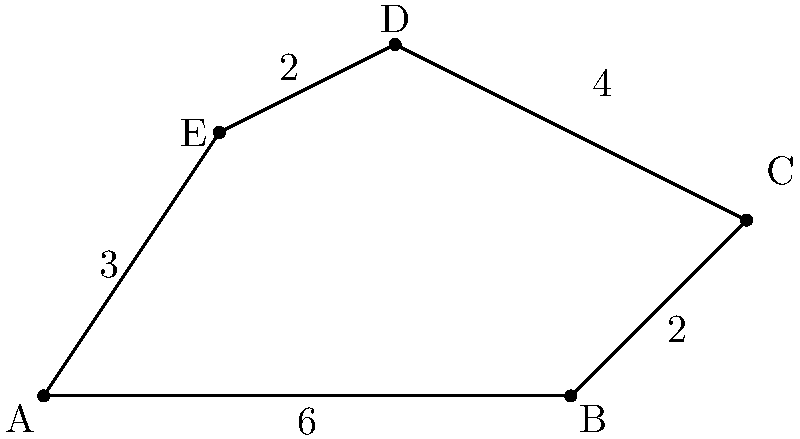In the context of poststructuralist analysis, consider the irregular pentagon ABCDE as a representation of the complex network of meanings in a text. If each unit of area corresponds to a layer of interpretation, calculate the total area of this textual landscape. Assume that the coordinates of the vertices are A(0,0), B(6,0), C(8,2), D(4,4), and E(2,3). To find the area of this irregular pentagon, we can use the shoelace formula (also known as the surveyor's formula). This method is particularly apt for our poststructuralist approach, as it weaves together different points to create a cohesive whole, much like how Derrida's theory of deconstruction reveals the interplay of meanings within a text.

Step 1: Apply the shoelace formula.
Area = $\frac{1}{2}|(x_1y_2 + x_2y_3 + x_3y_4 + x_4y_5 + x_5y_1) - (y_1x_2 + y_2x_3 + y_3x_4 + y_4x_5 + y_5x_1)|$

Step 2: Substitute the coordinates.
Area = $\frac{1}{2}|[(0 \cdot 0) + (6 \cdot 2) + (8 \cdot 4) + (4 \cdot 3) + (2 \cdot 0)] - [(0 \cdot 6) + (0 \cdot 8) + (2 \cdot 4) + (4 \cdot 2) + (3 \cdot 0)]|$

Step 3: Calculate the products.
Area = $\frac{1}{2}|[0 + 12 + 32 + 12 + 0] - [0 + 0 + 8 + 8 + 0]|$

Step 4: Sum the terms.
Area = $\frac{1}{2}|56 - 16|$

Step 5: Calculate the final result.
Area = $\frac{1}{2} \cdot 40 = 20$

This area of 20 square units represents the multifaceted nature of textual interpretation, where each unit symbolizes a layer of meaning that contributes to the overall understanding of the text. The irregular shape itself mirrors the non-linear and often unpredictable paths of deconstruction in poststructuralist analysis.
Answer: 20 square units 